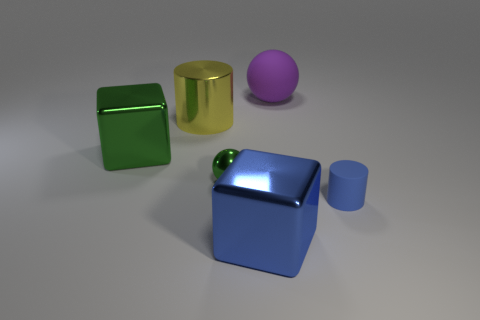There is a metal cylinder; is its color the same as the matte object that is right of the purple rubber object?
Offer a terse response. No. There is a large object that is the same color as the tiny shiny object; what is its material?
Offer a very short reply. Metal. How many big metallic cubes are the same color as the small metal ball?
Offer a terse response. 1. Is the color of the shiny cylinder the same as the tiny cylinder?
Make the answer very short. No. Are there any other things that are the same shape as the small matte object?
Your answer should be compact. Yes. Is the number of small brown objects less than the number of large purple rubber balls?
Offer a terse response. Yes. What color is the big metal cube that is to the left of the cylinder on the left side of the big purple object?
Offer a very short reply. Green. What is the big block on the right side of the big block that is behind the block that is right of the large yellow thing made of?
Your response must be concise. Metal. There is a purple matte object that is behind the rubber cylinder; is it the same size as the big green metallic block?
Offer a terse response. Yes. There is a big blue object right of the shiny cylinder; what is it made of?
Your answer should be compact. Metal. 